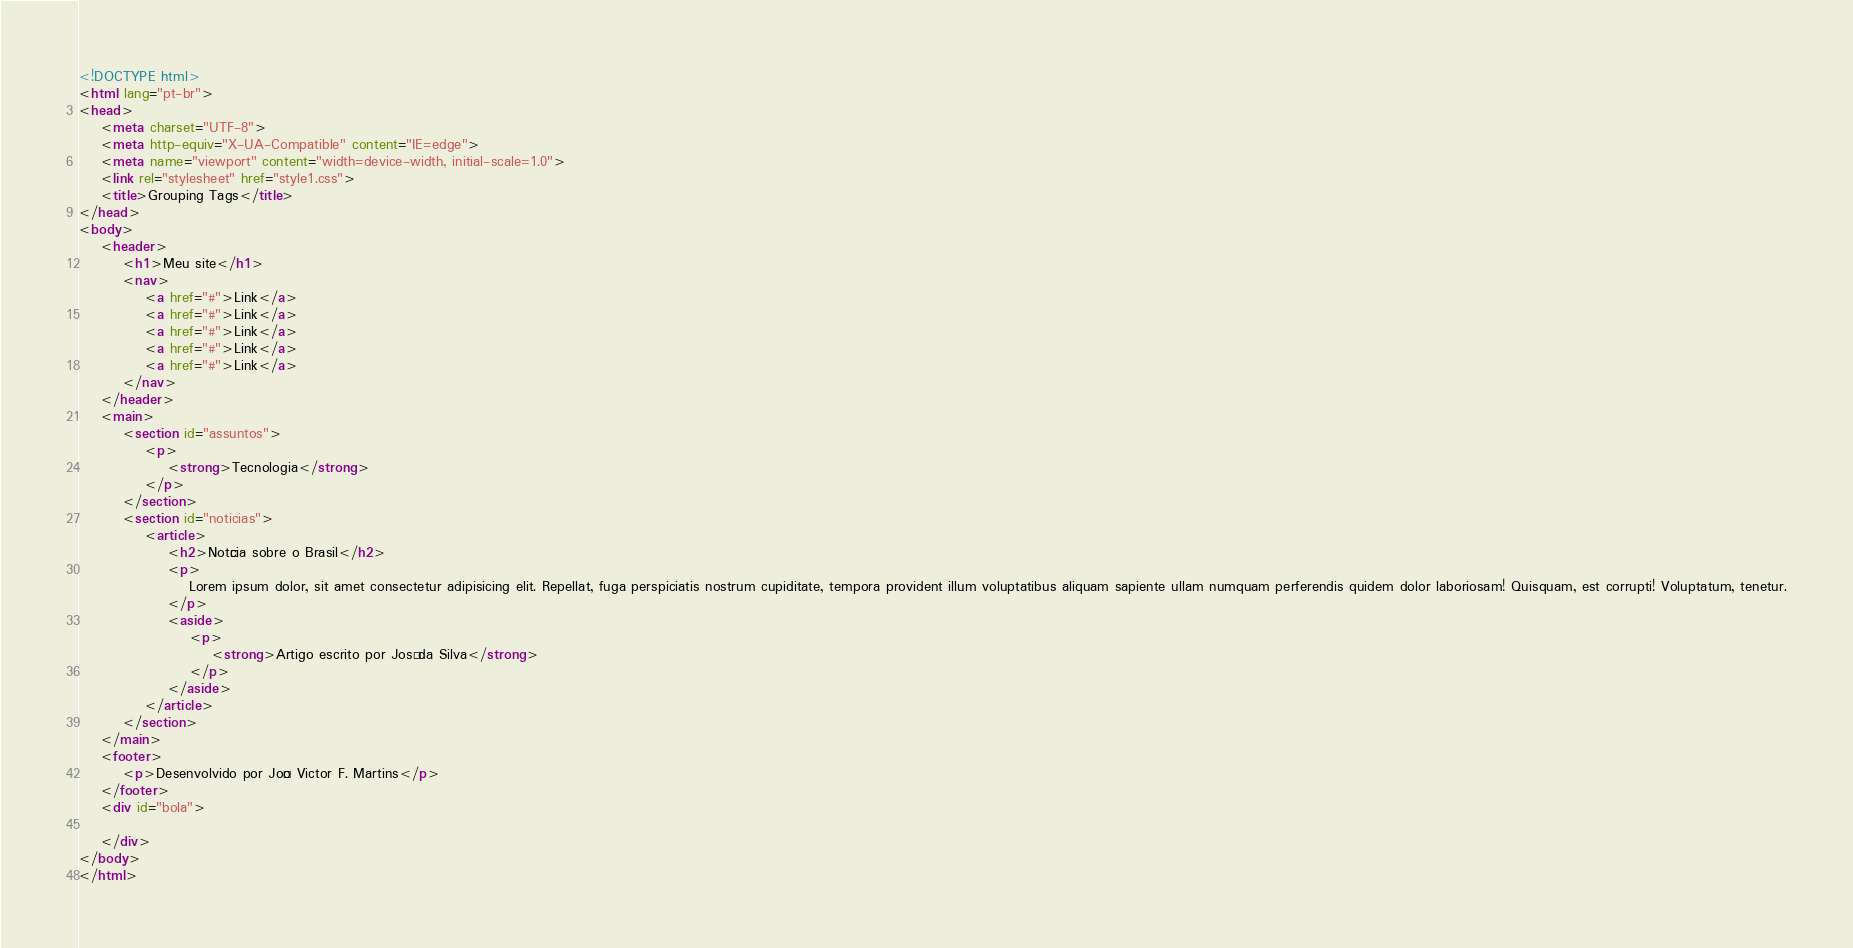Convert code to text. <code><loc_0><loc_0><loc_500><loc_500><_HTML_><!DOCTYPE html>
<html lang="pt-br">
<head>
    <meta charset="UTF-8">
    <meta http-equiv="X-UA-Compatible" content="IE=edge">
    <meta name="viewport" content="width=device-width, initial-scale=1.0">
    <link rel="stylesheet" href="style1.css">
    <title>Grouping Tags</title>
</head>
<body>
    <header>
        <h1>Meu site</h1>
        <nav>
            <a href="#">Link</a>
            <a href="#">Link</a>
            <a href="#">Link</a>
            <a href="#">Link</a>
            <a href="#">Link</a>
        </nav>
    </header>
    <main>
        <section id="assuntos">
            <p>
                <strong>Tecnologia</strong>
            </p>
        </section>
        <section id="noticias">
            <article>
                <h2>Notícia sobre o Brasil</h2>
                <p>
                    Lorem ipsum dolor, sit amet consectetur adipisicing elit. Repellat, fuga perspiciatis nostrum cupiditate, tempora provident illum voluptatibus aliquam sapiente ullam numquam perferendis quidem dolor laboriosam! Quisquam, est corrupti! Voluptatum, tenetur.
                </p>
                <aside>
                    <p>
                        <strong>Artigo escrito por José da Silva</strong>
                    </p>
                </aside>
            </article>
        </section>
    </main>
    <footer>
        <p>Desenvolvido por João Victor F. Martins</p>
    </footer>
    <div id="bola">

    </div>
</body>
</html></code> 